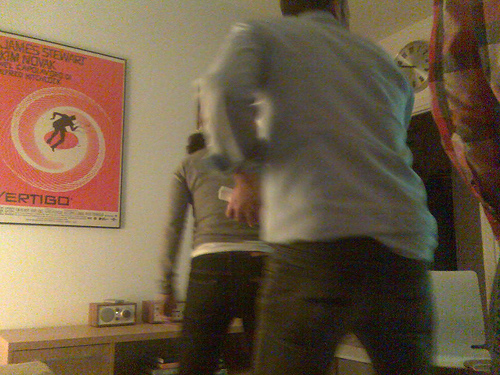Identify the text contained in this image. NOVAK ERTIGO 